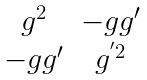<formula> <loc_0><loc_0><loc_500><loc_500>\begin{matrix} g ^ { 2 } & - g g ^ { \prime } \\ - g g ^ { \prime } & g ^ { ^ { \prime } 2 } \end{matrix}</formula> 